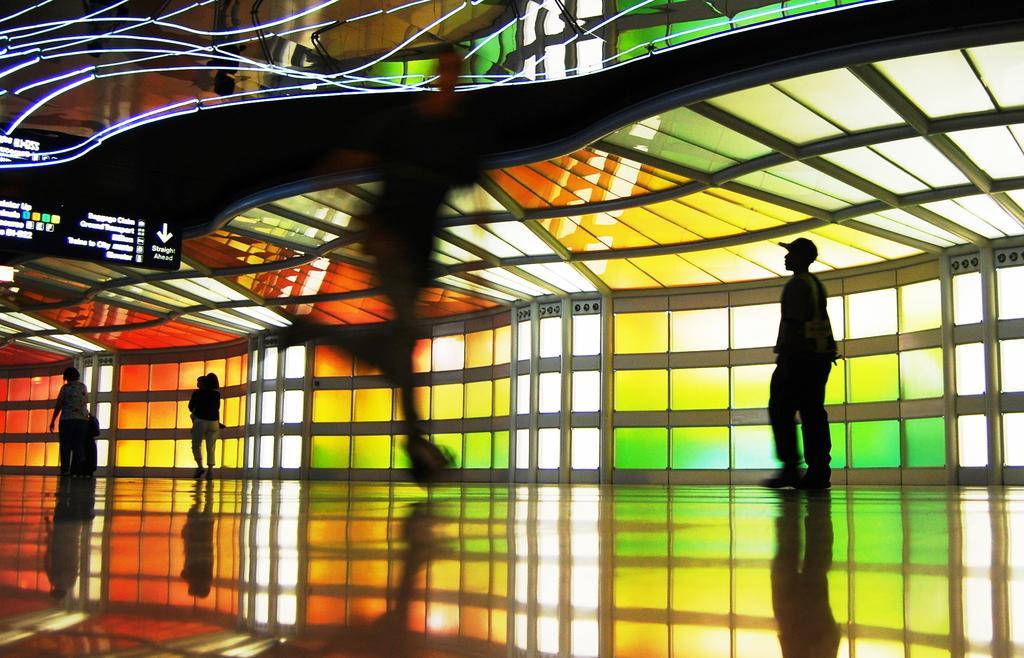Describe this image in one or two sentences. In the picture i can see some persons walking on floor, in the background of the picture there is a wall which is of glass are in different colors, top of the picture there is a board, roof. 